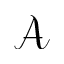Convert formula to latex. <formula><loc_0><loc_0><loc_500><loc_500>\mathcal { A }</formula> 